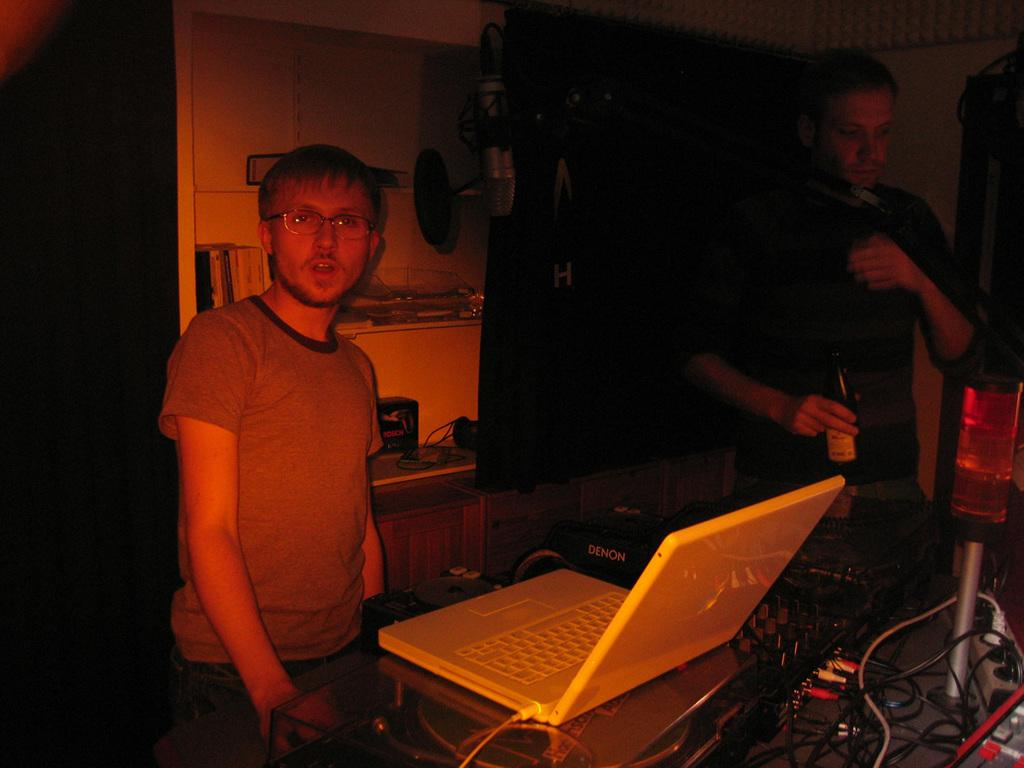How many people are in the image? There are two men in the image. What are the men doing in the image? The men are standing in front of a table. What can be seen on the table in the image? There is a laptop on the table, as well as other objects. What type of things does the man on the left offer to the man on the right in the image? There is no indication in the image that the men are offering anything to each other. 